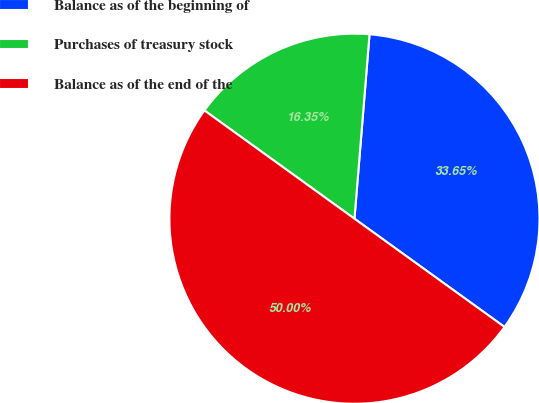Convert chart to OTSL. <chart><loc_0><loc_0><loc_500><loc_500><pie_chart><fcel>Balance as of the beginning of<fcel>Purchases of treasury stock<fcel>Balance as of the end of the<nl><fcel>33.65%<fcel>16.35%<fcel>50.0%<nl></chart> 